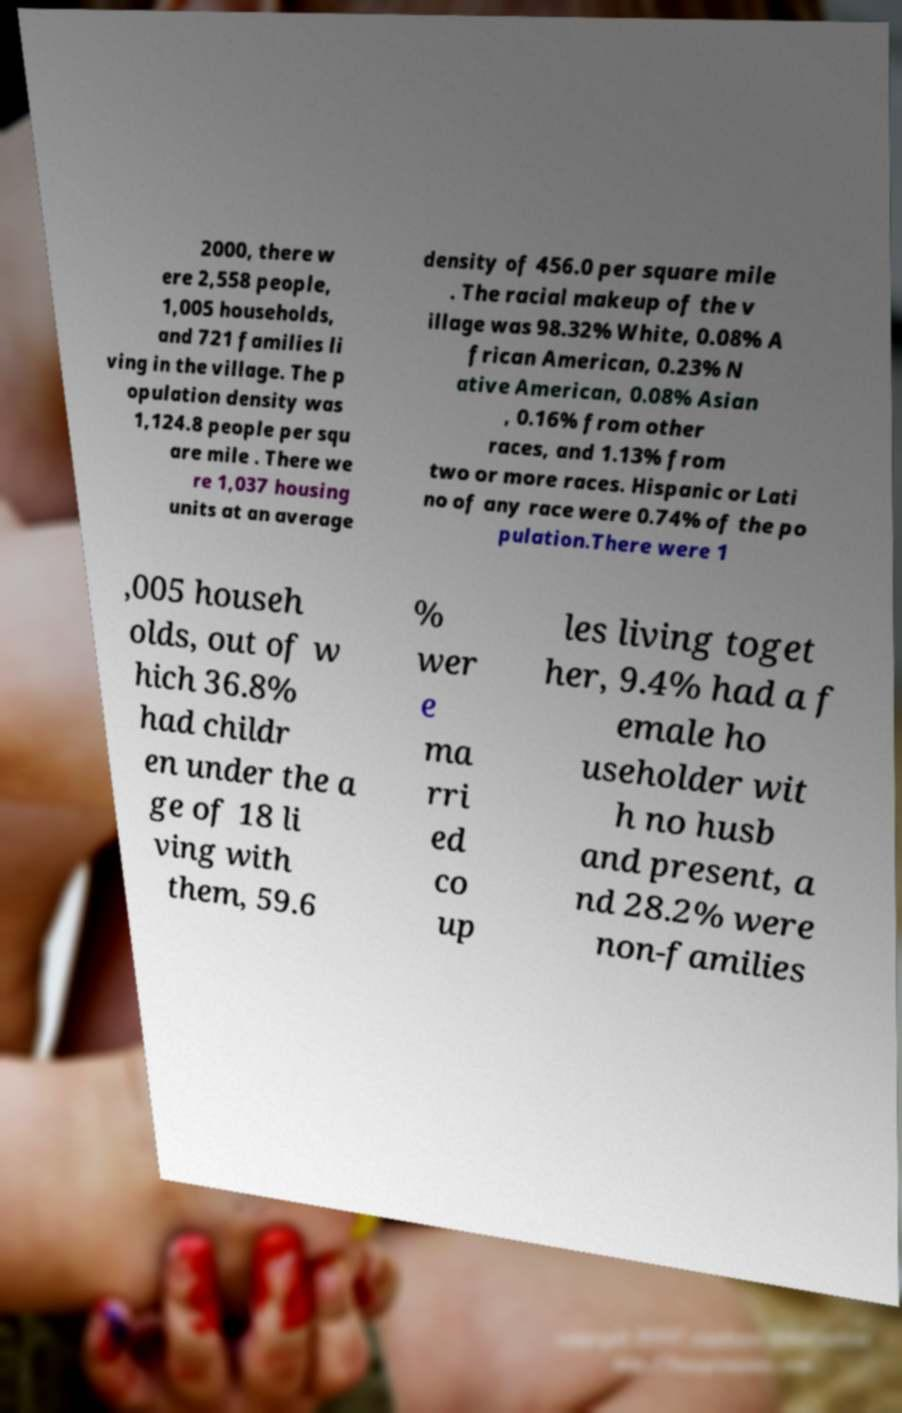Could you assist in decoding the text presented in this image and type it out clearly? 2000, there w ere 2,558 people, 1,005 households, and 721 families li ving in the village. The p opulation density was 1,124.8 people per squ are mile . There we re 1,037 housing units at an average density of 456.0 per square mile . The racial makeup of the v illage was 98.32% White, 0.08% A frican American, 0.23% N ative American, 0.08% Asian , 0.16% from other races, and 1.13% from two or more races. Hispanic or Lati no of any race were 0.74% of the po pulation.There were 1 ,005 househ olds, out of w hich 36.8% had childr en under the a ge of 18 li ving with them, 59.6 % wer e ma rri ed co up les living toget her, 9.4% had a f emale ho useholder wit h no husb and present, a nd 28.2% were non-families 